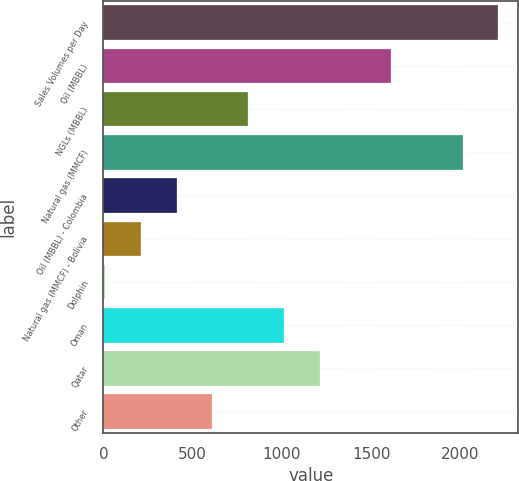Convert chart to OTSL. <chart><loc_0><loc_0><loc_500><loc_500><bar_chart><fcel>Sales Volumes per Day<fcel>Oil (MBBL)<fcel>NGLs (MBBL)<fcel>Natural gas (MMCF)<fcel>Oil (MBBL) - Colombia<fcel>Natural gas (MMCF) - Bolivia<fcel>Dolphin<fcel>Oman<fcel>Qatar<fcel>Other<nl><fcel>2211.2<fcel>1610.6<fcel>809.8<fcel>2011<fcel>409.4<fcel>209.2<fcel>9<fcel>1010<fcel>1210.2<fcel>609.6<nl></chart> 